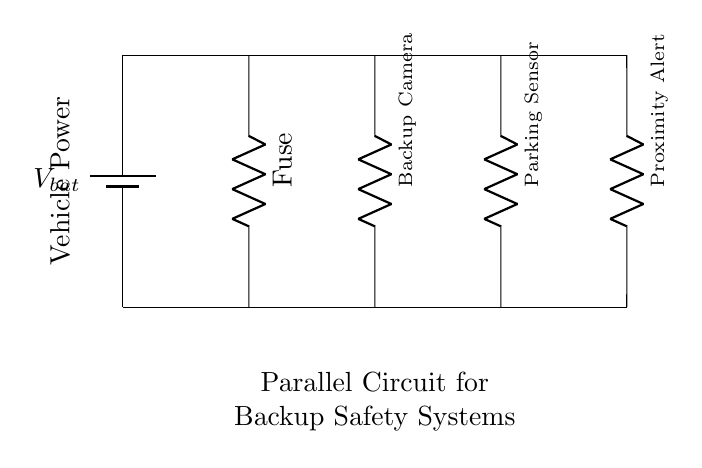What is the main power source for this circuit? The main power source is indicated at the top of the circuit diagram as the battery labeled V bat, which provides the necessary voltage for the backup sensors and cameras.
Answer: V bat How many components are connected in parallel in this circuit? The circuit diagram clearly shows three components connected in parallel: the Backup Camera, the Parking Sensor, and the Proximity Alert. Each is connected to the same voltage source from both sides, confirming the parallel configuration.
Answer: Three What is the purpose of the fuse in this circuit? The fuse is a safety device intended to protect the circuit from excessive current by breaking the circuit if the current exceeds a certain level. It is placed in the circuit before the other components to ensure they receive only safe levels of current.
Answer: Protection Which component is specifically designed for visual assistance? The component labeled as Backup Camera is explicitly designated for visual assistance while parking or maneuvering the vehicle, serving as a vital tool for increasing safety.
Answer: Backup Camera What happens if one component fails in this circuit? In a parallel circuit, if one component fails (such as the Parking Sensor), the other components (Backup Camera and Proximity Alert) will continue to operate normally, because each component has an independent connection to the power source. This characteristic makes parallel circuits advantageous for systems where reliability is critical.
Answer: Remaining components continue to work What is the overall circuit configuration shown? The circuit consists of a parallel configuration, evidenced by the multiple branches (Backup Camera, Parking Sensor, and Proximity Alert) sharing the same voltage supply while maintaining separate paths for current flow. This allows for independent operation of each component.
Answer: Parallel circuit 